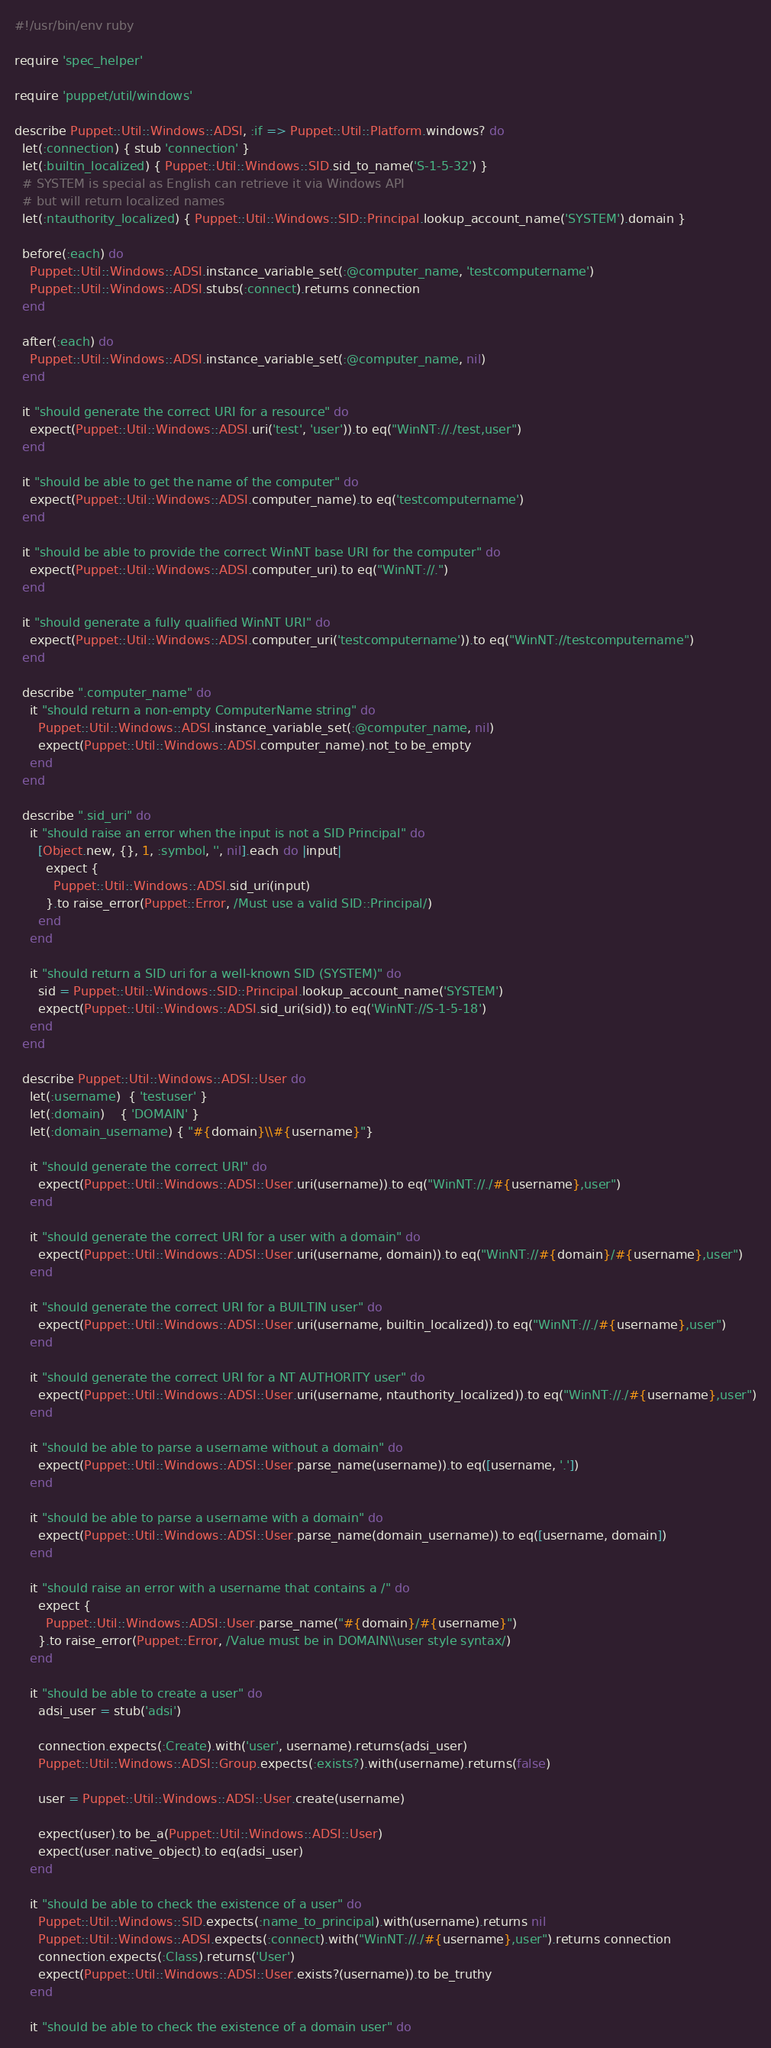Convert code to text. <code><loc_0><loc_0><loc_500><loc_500><_Ruby_>#!/usr/bin/env ruby

require 'spec_helper'

require 'puppet/util/windows'

describe Puppet::Util::Windows::ADSI, :if => Puppet::Util::Platform.windows? do
  let(:connection) { stub 'connection' }
  let(:builtin_localized) { Puppet::Util::Windows::SID.sid_to_name('S-1-5-32') }
  # SYSTEM is special as English can retrieve it via Windows API
  # but will return localized names
  let(:ntauthority_localized) { Puppet::Util::Windows::SID::Principal.lookup_account_name('SYSTEM').domain }

  before(:each) do
    Puppet::Util::Windows::ADSI.instance_variable_set(:@computer_name, 'testcomputername')
    Puppet::Util::Windows::ADSI.stubs(:connect).returns connection
  end

  after(:each) do
    Puppet::Util::Windows::ADSI.instance_variable_set(:@computer_name, nil)
  end

  it "should generate the correct URI for a resource" do
    expect(Puppet::Util::Windows::ADSI.uri('test', 'user')).to eq("WinNT://./test,user")
  end

  it "should be able to get the name of the computer" do
    expect(Puppet::Util::Windows::ADSI.computer_name).to eq('testcomputername')
  end

  it "should be able to provide the correct WinNT base URI for the computer" do
    expect(Puppet::Util::Windows::ADSI.computer_uri).to eq("WinNT://.")
  end

  it "should generate a fully qualified WinNT URI" do
    expect(Puppet::Util::Windows::ADSI.computer_uri('testcomputername')).to eq("WinNT://testcomputername")
  end

  describe ".computer_name" do
    it "should return a non-empty ComputerName string" do
      Puppet::Util::Windows::ADSI.instance_variable_set(:@computer_name, nil)
      expect(Puppet::Util::Windows::ADSI.computer_name).not_to be_empty
    end
  end

  describe ".sid_uri" do
    it "should raise an error when the input is not a SID Principal" do
      [Object.new, {}, 1, :symbol, '', nil].each do |input|
        expect {
          Puppet::Util::Windows::ADSI.sid_uri(input)
        }.to raise_error(Puppet::Error, /Must use a valid SID::Principal/)
      end
    end

    it "should return a SID uri for a well-known SID (SYSTEM)" do
      sid = Puppet::Util::Windows::SID::Principal.lookup_account_name('SYSTEM')
      expect(Puppet::Util::Windows::ADSI.sid_uri(sid)).to eq('WinNT://S-1-5-18')
    end
  end

  describe Puppet::Util::Windows::ADSI::User do
    let(:username)  { 'testuser' }
    let(:domain)    { 'DOMAIN' }
    let(:domain_username) { "#{domain}\\#{username}"}

    it "should generate the correct URI" do
      expect(Puppet::Util::Windows::ADSI::User.uri(username)).to eq("WinNT://./#{username},user")
    end

    it "should generate the correct URI for a user with a domain" do
      expect(Puppet::Util::Windows::ADSI::User.uri(username, domain)).to eq("WinNT://#{domain}/#{username},user")
    end

    it "should generate the correct URI for a BUILTIN user" do
      expect(Puppet::Util::Windows::ADSI::User.uri(username, builtin_localized)).to eq("WinNT://./#{username},user")
    end

    it "should generate the correct URI for a NT AUTHORITY user" do
      expect(Puppet::Util::Windows::ADSI::User.uri(username, ntauthority_localized)).to eq("WinNT://./#{username},user")
    end

    it "should be able to parse a username without a domain" do
      expect(Puppet::Util::Windows::ADSI::User.parse_name(username)).to eq([username, '.'])
    end

    it "should be able to parse a username with a domain" do
      expect(Puppet::Util::Windows::ADSI::User.parse_name(domain_username)).to eq([username, domain])
    end

    it "should raise an error with a username that contains a /" do
      expect {
        Puppet::Util::Windows::ADSI::User.parse_name("#{domain}/#{username}")
      }.to raise_error(Puppet::Error, /Value must be in DOMAIN\\user style syntax/)
    end

    it "should be able to create a user" do
      adsi_user = stub('adsi')

      connection.expects(:Create).with('user', username).returns(adsi_user)
      Puppet::Util::Windows::ADSI::Group.expects(:exists?).with(username).returns(false)

      user = Puppet::Util::Windows::ADSI::User.create(username)

      expect(user).to be_a(Puppet::Util::Windows::ADSI::User)
      expect(user.native_object).to eq(adsi_user)
    end

    it "should be able to check the existence of a user" do
      Puppet::Util::Windows::SID.expects(:name_to_principal).with(username).returns nil
      Puppet::Util::Windows::ADSI.expects(:connect).with("WinNT://./#{username},user").returns connection
      connection.expects(:Class).returns('User')
      expect(Puppet::Util::Windows::ADSI::User.exists?(username)).to be_truthy
    end

    it "should be able to check the existence of a domain user" do</code> 